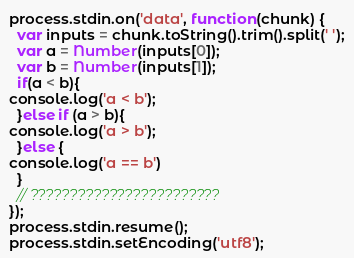Convert code to text. <code><loc_0><loc_0><loc_500><loc_500><_JavaScript_>process.stdin.on('data', function(chunk) {
  var inputs = chunk.toString().trim().split(' ');
  var a = Number(inputs[0]);
  var b = Number(inputs[1]);
  if(a < b){
console.log('a < b');
  }else if (a > b){
console.log('a > b');
  }else {
console.log('a == b')
  }
  // ????????????????????????
});
process.stdin.resume();
process.stdin.setEncoding('utf8');</code> 